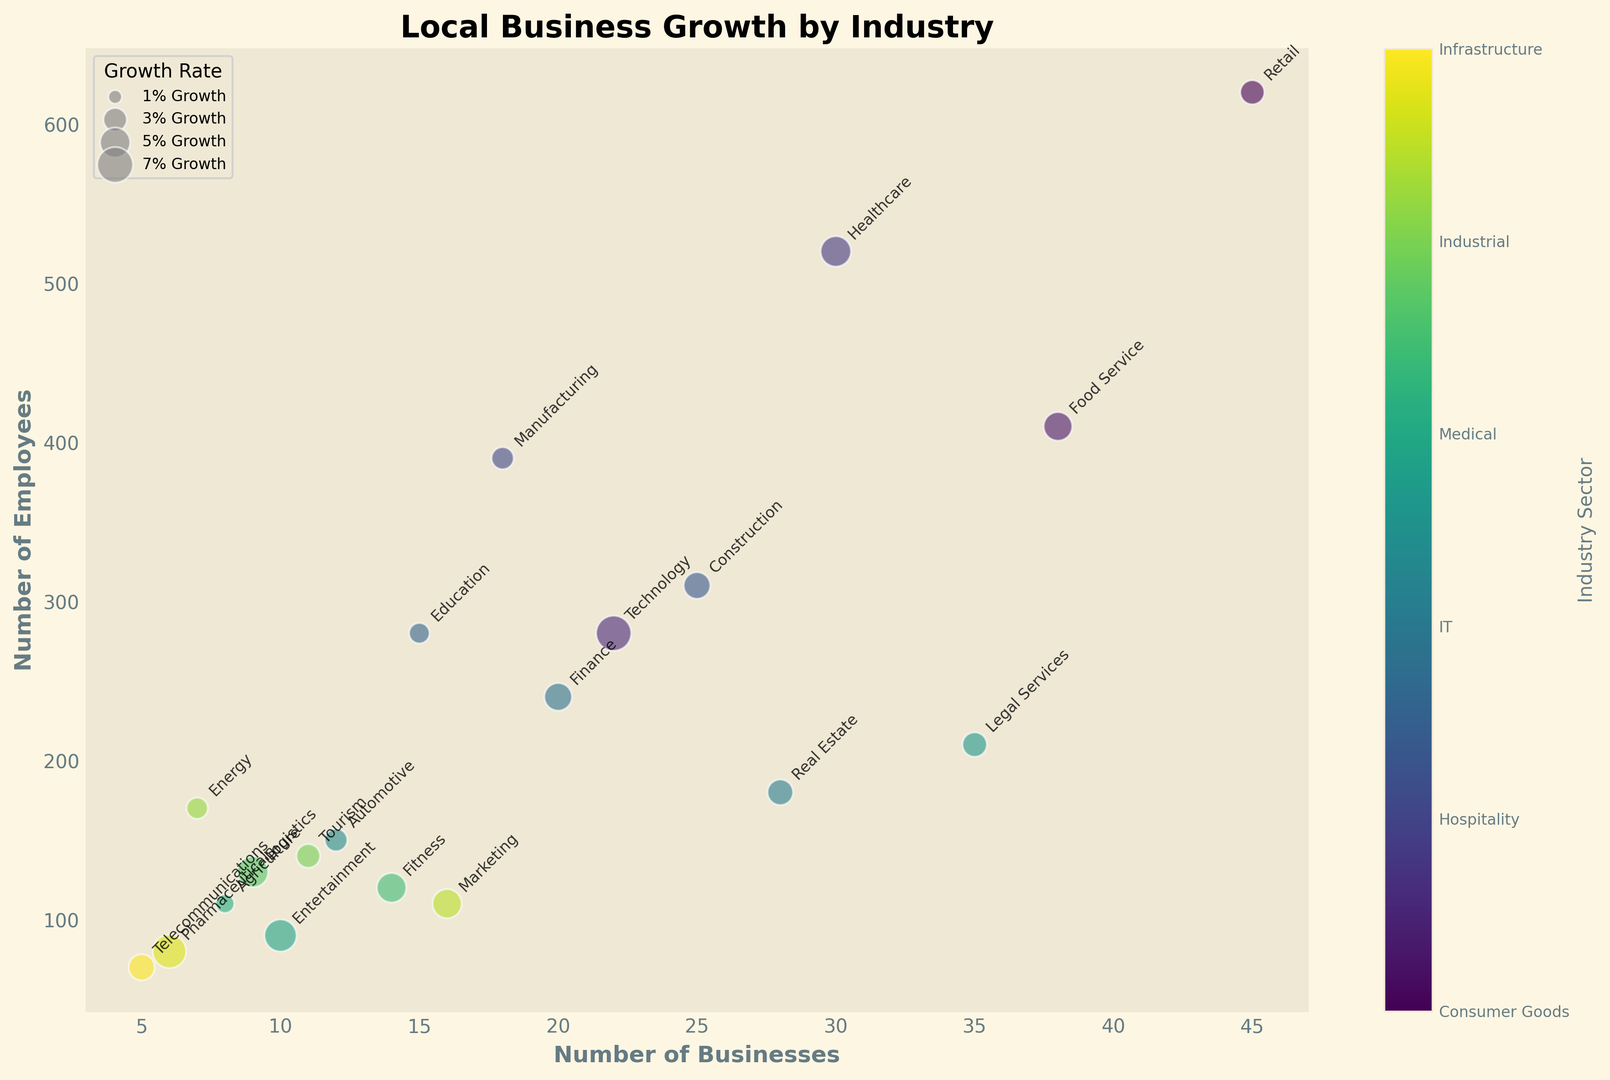Which industry has the most businesses? Look for the bubble located farthest to the right, representing the highest number of businesses. The Retail industry has the highest business count.
Answer: Retail How many industries have more than 500 employees? Look at the bubbles positioned above the y-axis value of 500. Count these bubbles to identify the industries. There are two industries with more than 500 employees: Retail and Healthcare.
Answer: 2 What is the growth rate of the industry with the least number of businesses? Identify the smallest bubble on the x-axis, representing the lowest number of businesses. Telecommunications has the least number of businesses with a growth rate of 3.8%.
Answer: 3.8% Which industry sector has the highest growth rate, and what is its growth rate? Identify the largest bubble in terms of size, indicating the highest growth rate. Technology in the IT sector has the highest growth rate of 6.8%.
Answer: Technology, 6.8% What is the combined number of employees in the Food Service and Healthcare industries? Find the bubbles representing these industries and sum their employee counts (Food Service: 410; Healthcare: 520). The combined number of employees is 410 + 520 = 930.
Answer: 930 Which industry sector has both fewer than 15 businesses and more than a 5% growth rate? Identify bubbles located to the left of x=15 and sized appropriately. Entertainment (Media) and Telecommunications (Communications) fit these criteria.
Answer: Entertainment, Telecommunications How does the employee count of the Construction industry compare to that of the Education industry? Locate the Construction bubble and the Education bubble to compare their vertical positions on the y-axis. Construction has 310 employees, whereas Education has 280 employees. Thus, Construction has more employees than Education.
Answer: Construction has more Which industries fall under the Services sector, and how many businesses do they have in total? Identify industries labeled under the "Services" sector and sum their business counts. Education (15 businesses), Finance (20 businesses), and Legal Services (35 businesses) fall under Services. The total is 15 + 20 + 35 = 70.
Answer: Education, Finance, Legal Services; 70 What is the average growth rate across all industries shown in the chart? Sum all the growth rates and divide by the number of industries. Sum = 3.2 + 4.5 + 6.8 + 5.1 + 2.7 + 3.9 + 2.3 + 4.2 + 3.6 + 2.8 + 3.3 + 5.7 + 1.9 + 4.8 + 5.3 + 3.1 + 2.5 + 4.7 + 6.2 + 3.8 = 84.4; Average = 84.4 / 20 = 4.22.
Answer: 4.22% Between the Retail and Finance industries, which has a higher growth rate and by how much? Compare the growth rates of Retail (3.2%) and Finance (4.2%). Finance has a higher growth rate. The difference is 4.2% - 3.2% = 1%.
Answer: Finance by 1% 